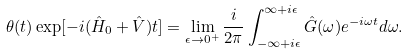<formula> <loc_0><loc_0><loc_500><loc_500>\theta ( t ) \exp [ - i ( \hat { H } _ { 0 } + \hat { V } ) t ] = \lim _ { \epsilon \rightarrow 0 ^ { + } } \frac { i } { 2 \pi } \int _ { - \infty + i \epsilon } ^ { \infty + i \epsilon } \hat { G } ( \omega ) e ^ { - i \omega t } d \omega .</formula> 